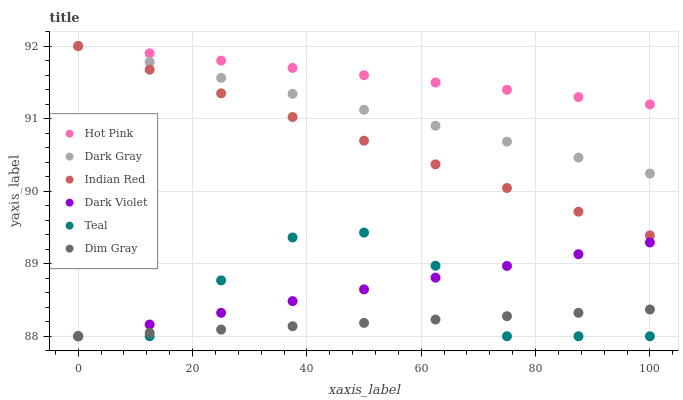Does Dim Gray have the minimum area under the curve?
Answer yes or no. Yes. Does Hot Pink have the maximum area under the curve?
Answer yes or no. Yes. Does Indian Red have the minimum area under the curve?
Answer yes or no. No. Does Indian Red have the maximum area under the curve?
Answer yes or no. No. Is Hot Pink the smoothest?
Answer yes or no. Yes. Is Teal the roughest?
Answer yes or no. Yes. Is Indian Red the smoothest?
Answer yes or no. No. Is Indian Red the roughest?
Answer yes or no. No. Does Dim Gray have the lowest value?
Answer yes or no. Yes. Does Indian Red have the lowest value?
Answer yes or no. No. Does Dark Gray have the highest value?
Answer yes or no. Yes. Does Dark Violet have the highest value?
Answer yes or no. No. Is Teal less than Hot Pink?
Answer yes or no. Yes. Is Indian Red greater than Teal?
Answer yes or no. Yes. Does Dark Gray intersect Hot Pink?
Answer yes or no. Yes. Is Dark Gray less than Hot Pink?
Answer yes or no. No. Is Dark Gray greater than Hot Pink?
Answer yes or no. No. Does Teal intersect Hot Pink?
Answer yes or no. No. 